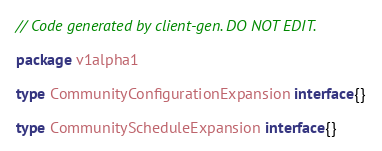Convert code to text. <code><loc_0><loc_0><loc_500><loc_500><_Go_>// Code generated by client-gen. DO NOT EDIT.

package v1alpha1

type CommunityConfigurationExpansion interface{}

type CommunityScheduleExpansion interface{}
</code> 